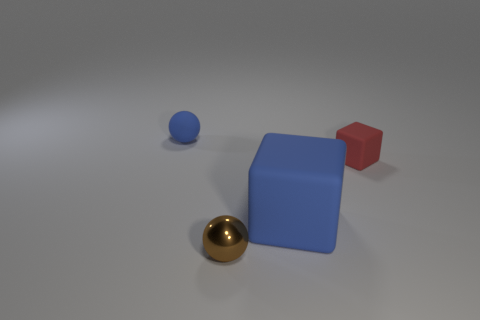What is the size of the blue thing that is the same material as the blue sphere?
Give a very brief answer. Large. Is the color of the large matte object the same as the rubber ball?
Provide a succinct answer. Yes. There is a tiny rubber thing that is on the left side of the small brown shiny ball; is its shape the same as the large blue matte thing?
Make the answer very short. No. What number of red matte blocks have the same size as the blue rubber sphere?
Offer a very short reply. 1. What is the shape of the large thing that is the same color as the rubber ball?
Provide a short and direct response. Cube. There is a rubber thing in front of the red block; is there a small rubber thing on the left side of it?
Offer a very short reply. Yes. What number of things are either big matte things that are right of the brown object or big cyan objects?
Offer a very short reply. 1. What number of large yellow rubber balls are there?
Keep it short and to the point. 0. The other tiny thing that is the same material as the tiny red thing is what shape?
Offer a terse response. Sphere. There is a blue object that is in front of the sphere that is behind the tiny shiny object; what is its size?
Keep it short and to the point. Large. 